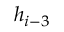<formula> <loc_0><loc_0><loc_500><loc_500>h _ { i - 3 }</formula> 